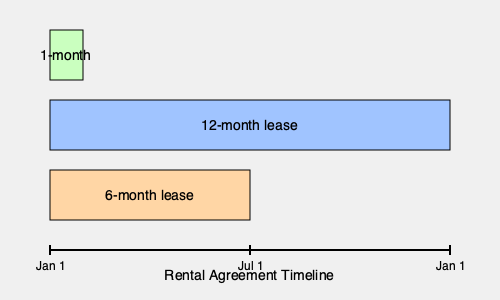Based on the rental agreement timeline shown, which type of lease offers the most flexibility for a tenant who is unsure about their long-term plans in the United States? To determine which type of lease offers the most flexibility, let's analyze each option:

1. 12-month lease:
   - Spans the entire timeline from Jan 1 to Jan 1 of the following year
   - Provides stability but less flexibility for early termination

2. 6-month lease:
   - Spans from Jan 1 to Jul 1
   - Offers more flexibility than the 12-month lease, allowing for reassessment after half a year

3. 1-month lease:
   - Spans only the first month (Jan 1 to Feb 1)
   - Provides the most flexibility, allowing the tenant to:
     a) Renew on a month-to-month basis
     b) Easily terminate the lease with minimal notice
     c) Quickly adapt to changing circumstances or plans

For a tenant unsure about their long-term plans in the United States, the 1-month lease offers the greatest flexibility. It allows for quick adjustments to living arrangements without the commitment of a longer-term lease, which is particularly beneficial for someone new to the country and still adapting to their new environment.
Answer: 1-month lease 